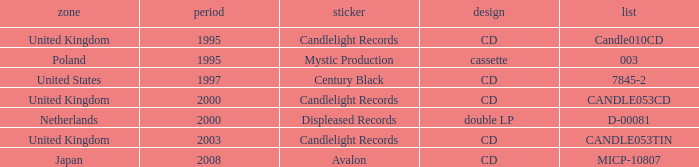What is Candlelight Records format? CD, CD, CD. 